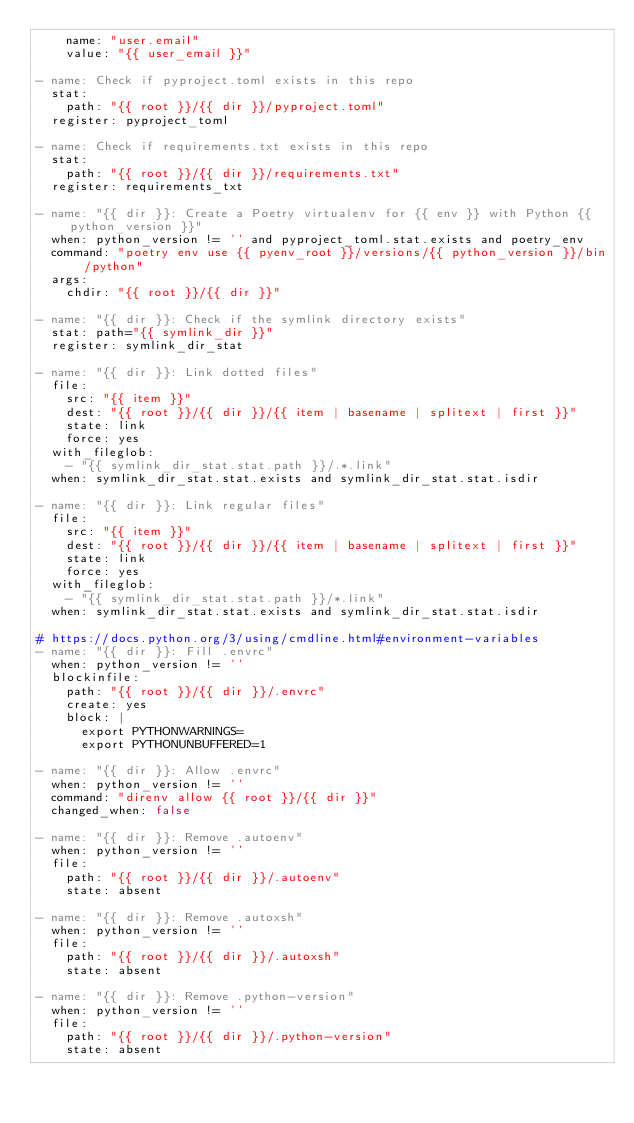Convert code to text. <code><loc_0><loc_0><loc_500><loc_500><_YAML_>    name: "user.email"
    value: "{{ user_email }}"

- name: Check if pyproject.toml exists in this repo
  stat:
    path: "{{ root }}/{{ dir }}/pyproject.toml"
  register: pyproject_toml

- name: Check if requirements.txt exists in this repo
  stat:
    path: "{{ root }}/{{ dir }}/requirements.txt"
  register: requirements_txt

- name: "{{ dir }}: Create a Poetry virtualenv for {{ env }} with Python {{ python_version }}"
  when: python_version != '' and pyproject_toml.stat.exists and poetry_env
  command: "poetry env use {{ pyenv_root }}/versions/{{ python_version }}/bin/python"
  args:
    chdir: "{{ root }}/{{ dir }}"

- name: "{{ dir }}: Check if the symlink directory exists"
  stat: path="{{ symlink_dir }}"
  register: symlink_dir_stat

- name: "{{ dir }}: Link dotted files"
  file:
    src: "{{ item }}"
    dest: "{{ root }}/{{ dir }}/{{ item | basename | splitext | first }}"
    state: link
    force: yes
  with_fileglob:
    - "{{ symlink_dir_stat.stat.path }}/.*.link"
  when: symlink_dir_stat.stat.exists and symlink_dir_stat.stat.isdir

- name: "{{ dir }}: Link regular files"
  file:
    src: "{{ item }}"
    dest: "{{ root }}/{{ dir }}/{{ item | basename | splitext | first }}"
    state: link
    force: yes
  with_fileglob:
    - "{{ symlink_dir_stat.stat.path }}/*.link"
  when: symlink_dir_stat.stat.exists and symlink_dir_stat.stat.isdir

# https://docs.python.org/3/using/cmdline.html#environment-variables
- name: "{{ dir }}: Fill .envrc"
  when: python_version != ''
  blockinfile:
    path: "{{ root }}/{{ dir }}/.envrc"
    create: yes
    block: |
      export PYTHONWARNINGS=
      export PYTHONUNBUFFERED=1

- name: "{{ dir }}: Allow .envrc"
  when: python_version != ''
  command: "direnv allow {{ root }}/{{ dir }}"
  changed_when: false

- name: "{{ dir }}: Remove .autoenv"
  when: python_version != ''
  file:
    path: "{{ root }}/{{ dir }}/.autoenv"
    state: absent

- name: "{{ dir }}: Remove .autoxsh"
  when: python_version != ''
  file:
    path: "{{ root }}/{{ dir }}/.autoxsh"
    state: absent

- name: "{{ dir }}: Remove .python-version"
  when: python_version != ''
  file:
    path: "{{ root }}/{{ dir }}/.python-version"
    state: absent
</code> 